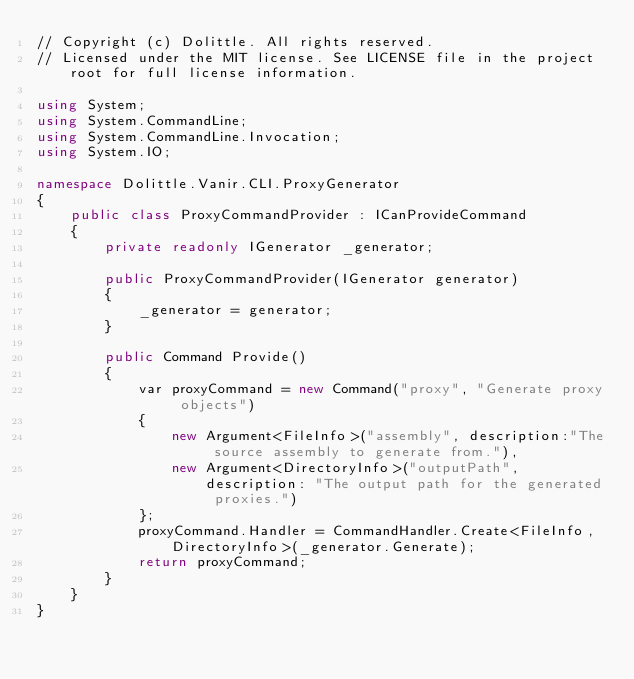Convert code to text. <code><loc_0><loc_0><loc_500><loc_500><_C#_>// Copyright (c) Dolittle. All rights reserved.
// Licensed under the MIT license. See LICENSE file in the project root for full license information.

using System;
using System.CommandLine;
using System.CommandLine.Invocation;
using System.IO;

namespace Dolittle.Vanir.CLI.ProxyGenerator
{
    public class ProxyCommandProvider : ICanProvideCommand
    {
        private readonly IGenerator _generator;

        public ProxyCommandProvider(IGenerator generator)
        {
            _generator = generator;
        }

        public Command Provide()
        {
            var proxyCommand = new Command("proxy", "Generate proxy objects")
            {
                new Argument<FileInfo>("assembly", description:"The source assembly to generate from."),
                new Argument<DirectoryInfo>("outputPath", description: "The output path for the generated proxies.")
            };
            proxyCommand.Handler = CommandHandler.Create<FileInfo, DirectoryInfo>(_generator.Generate);
            return proxyCommand;
        }
    }
}
</code> 